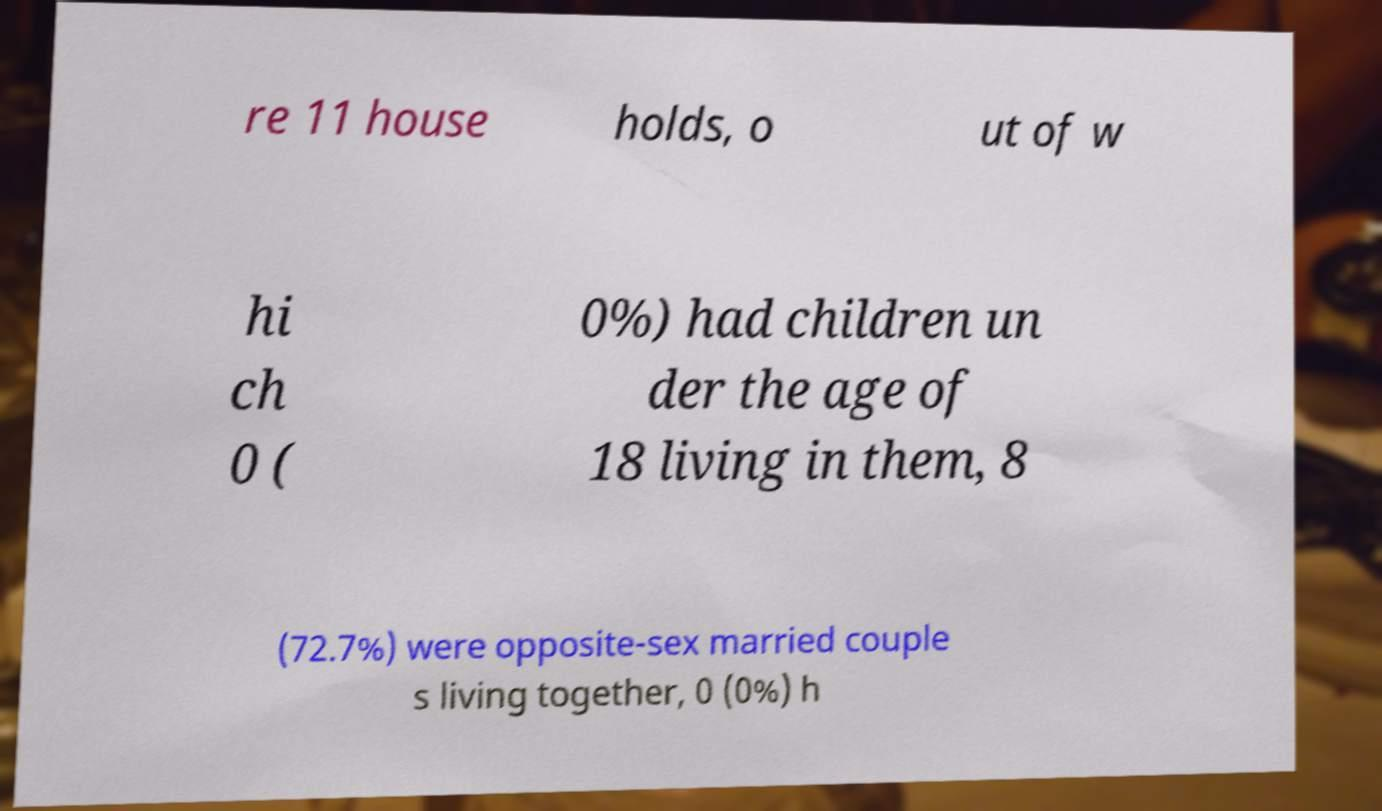For documentation purposes, I need the text within this image transcribed. Could you provide that? re 11 house holds, o ut of w hi ch 0 ( 0%) had children un der the age of 18 living in them, 8 (72.7%) were opposite-sex married couple s living together, 0 (0%) h 